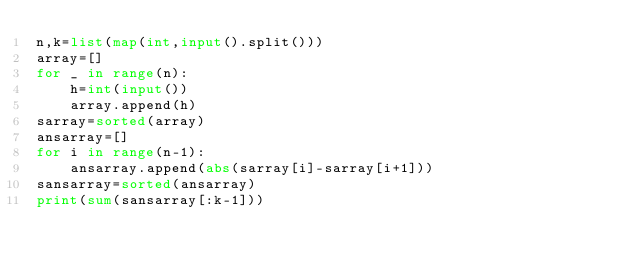<code> <loc_0><loc_0><loc_500><loc_500><_Python_>n,k=list(map(int,input().split()))
array=[]
for _ in range(n):
	h=int(input())
	array.append(h)
sarray=sorted(array)
ansarray=[]
for i in range(n-1):
	ansarray.append(abs(sarray[i]-sarray[i+1]))
sansarray=sorted(ansarray)
print(sum(sansarray[:k-1]))
</code> 